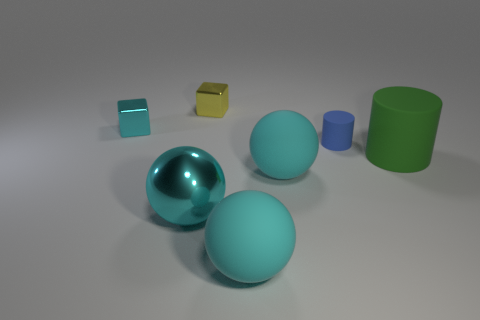There is a big ball in front of the big metallic thing; is its color the same as the big shiny sphere?
Make the answer very short. Yes. How many cyan spheres are left of the small cube that is right of the cyan object behind the tiny cylinder?
Ensure brevity in your answer.  1. How big is the blue matte object?
Your response must be concise. Small. There is a cyan metallic object behind the green matte thing; what is its size?
Your answer should be compact. Small. Does the big thing on the right side of the tiny blue thing have the same color as the rubber thing that is behind the green matte object?
Ensure brevity in your answer.  No. What number of other objects are there of the same shape as the big cyan metal object?
Make the answer very short. 2. Are there the same number of small blue cylinders that are in front of the cyan metallic sphere and small metallic objects right of the large green thing?
Give a very brief answer. Yes. Is the material of the cube that is to the right of the small cyan shiny cube the same as the cylinder behind the green thing?
Provide a short and direct response. No. What number of other things are the same size as the green thing?
Your answer should be compact. 3. How many things are either small yellow metal cylinders or large rubber objects that are in front of the big shiny ball?
Your answer should be very brief. 1. 